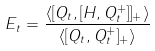Convert formula to latex. <formula><loc_0><loc_0><loc_500><loc_500>E _ { t } = \frac { \langle [ Q _ { t } , [ H , Q _ { t } ^ { + } ] ] _ { + } \rangle } { \langle [ Q _ { t } , Q _ { t } ^ { + } ] _ { + } \rangle }</formula> 